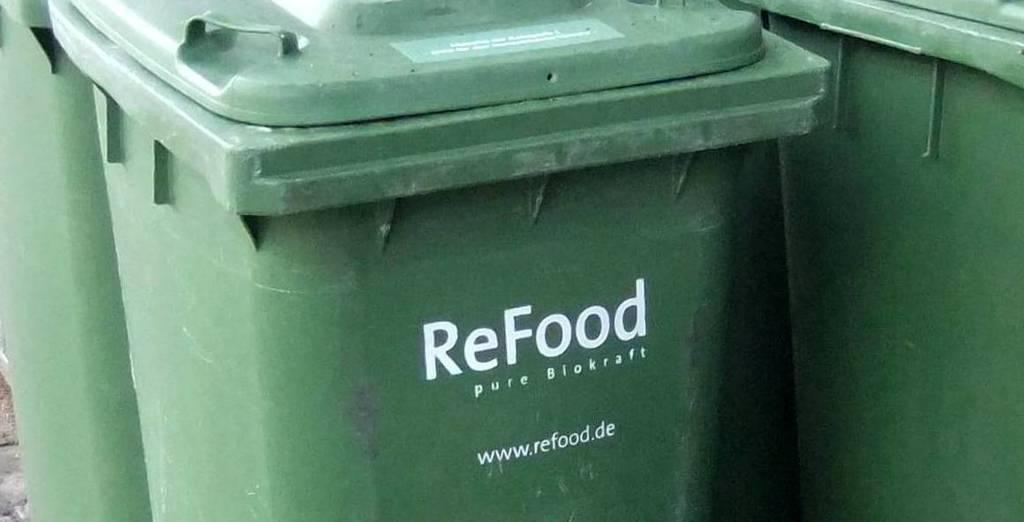<image>
Write a terse but informative summary of the picture. Green garbage can which says the word ReFood on it. 